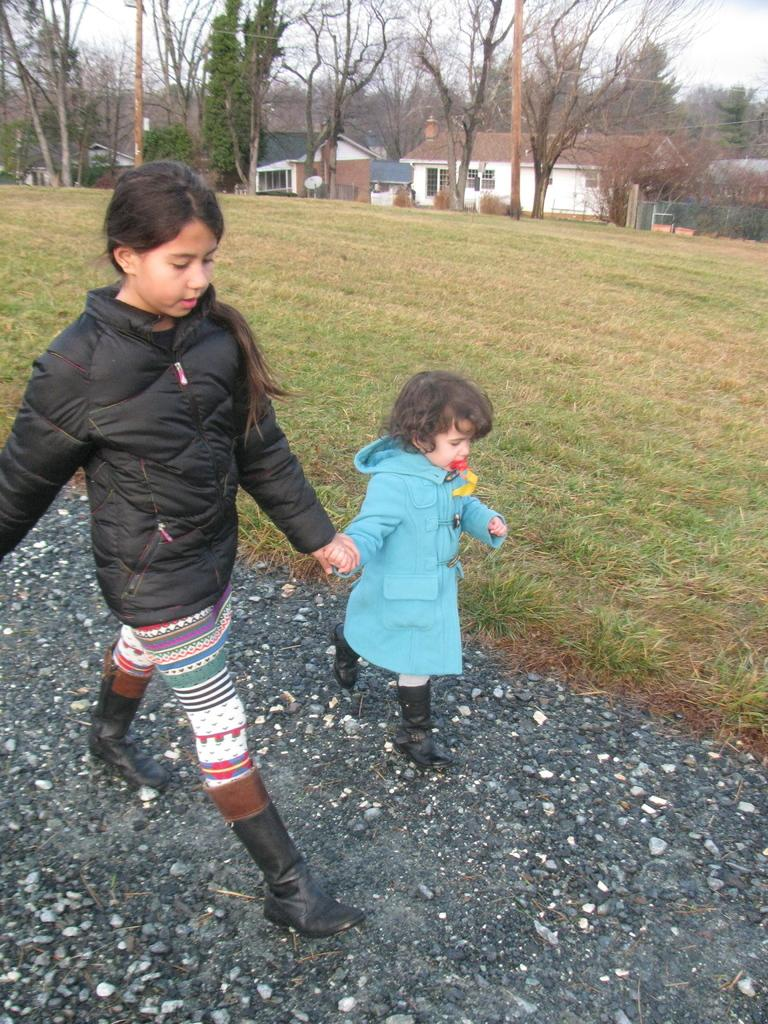What are the main subjects in the image? There are two girls walking in the image. What can be seen in the background of the image? There are houses and trees in the background of the image. What is visible at the top of the image? The sky is visible at the top of the image. What type of polish is being applied to the trees in the image? There is no indication in the image that any polish is being applied to the trees; they appear to be natural. 